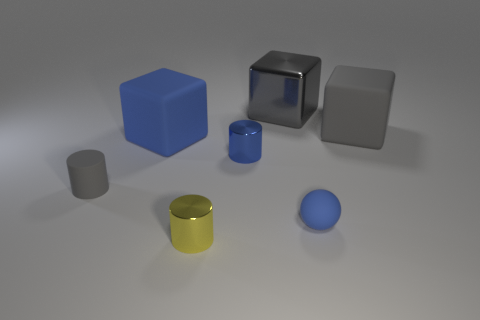How many other things are there of the same size as the blue matte cube? There are two objects that appear to have a similar size to the blue matte cube - a grey cube and a metallic grey cube with a slight reflection. 